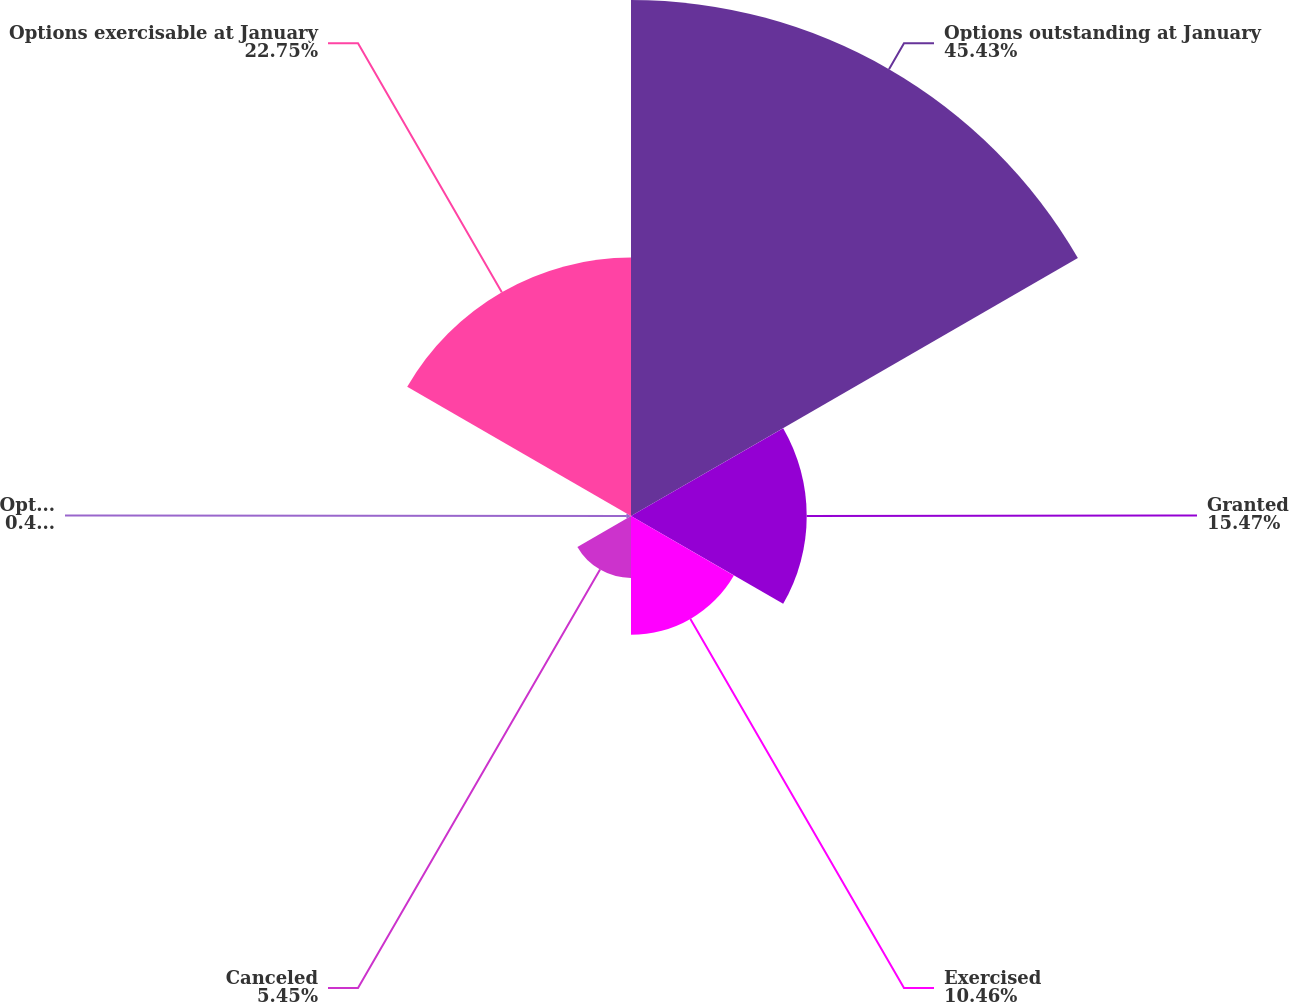Convert chart to OTSL. <chart><loc_0><loc_0><loc_500><loc_500><pie_chart><fcel>Options outstanding at January<fcel>Granted<fcel>Exercised<fcel>Canceled<fcel>Options assumed in<fcel>Options exercisable at January<nl><fcel>45.43%<fcel>15.47%<fcel>10.46%<fcel>5.45%<fcel>0.44%<fcel>22.75%<nl></chart> 